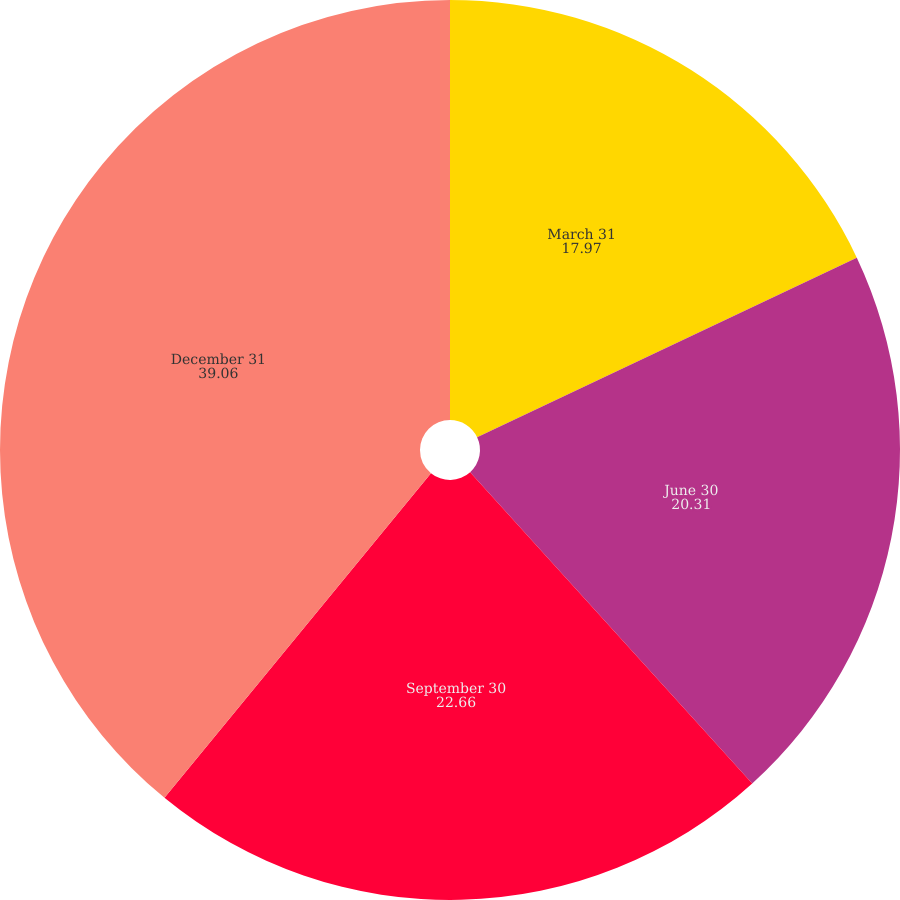Convert chart. <chart><loc_0><loc_0><loc_500><loc_500><pie_chart><fcel>March 31<fcel>June 30<fcel>September 30<fcel>December 31<nl><fcel>17.97%<fcel>20.31%<fcel>22.66%<fcel>39.06%<nl></chart> 